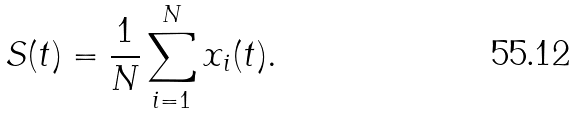Convert formula to latex. <formula><loc_0><loc_0><loc_500><loc_500>S ( t ) = \frac { 1 } { N } \sum _ { i = 1 } ^ { N } x _ { i } ( t ) .</formula> 